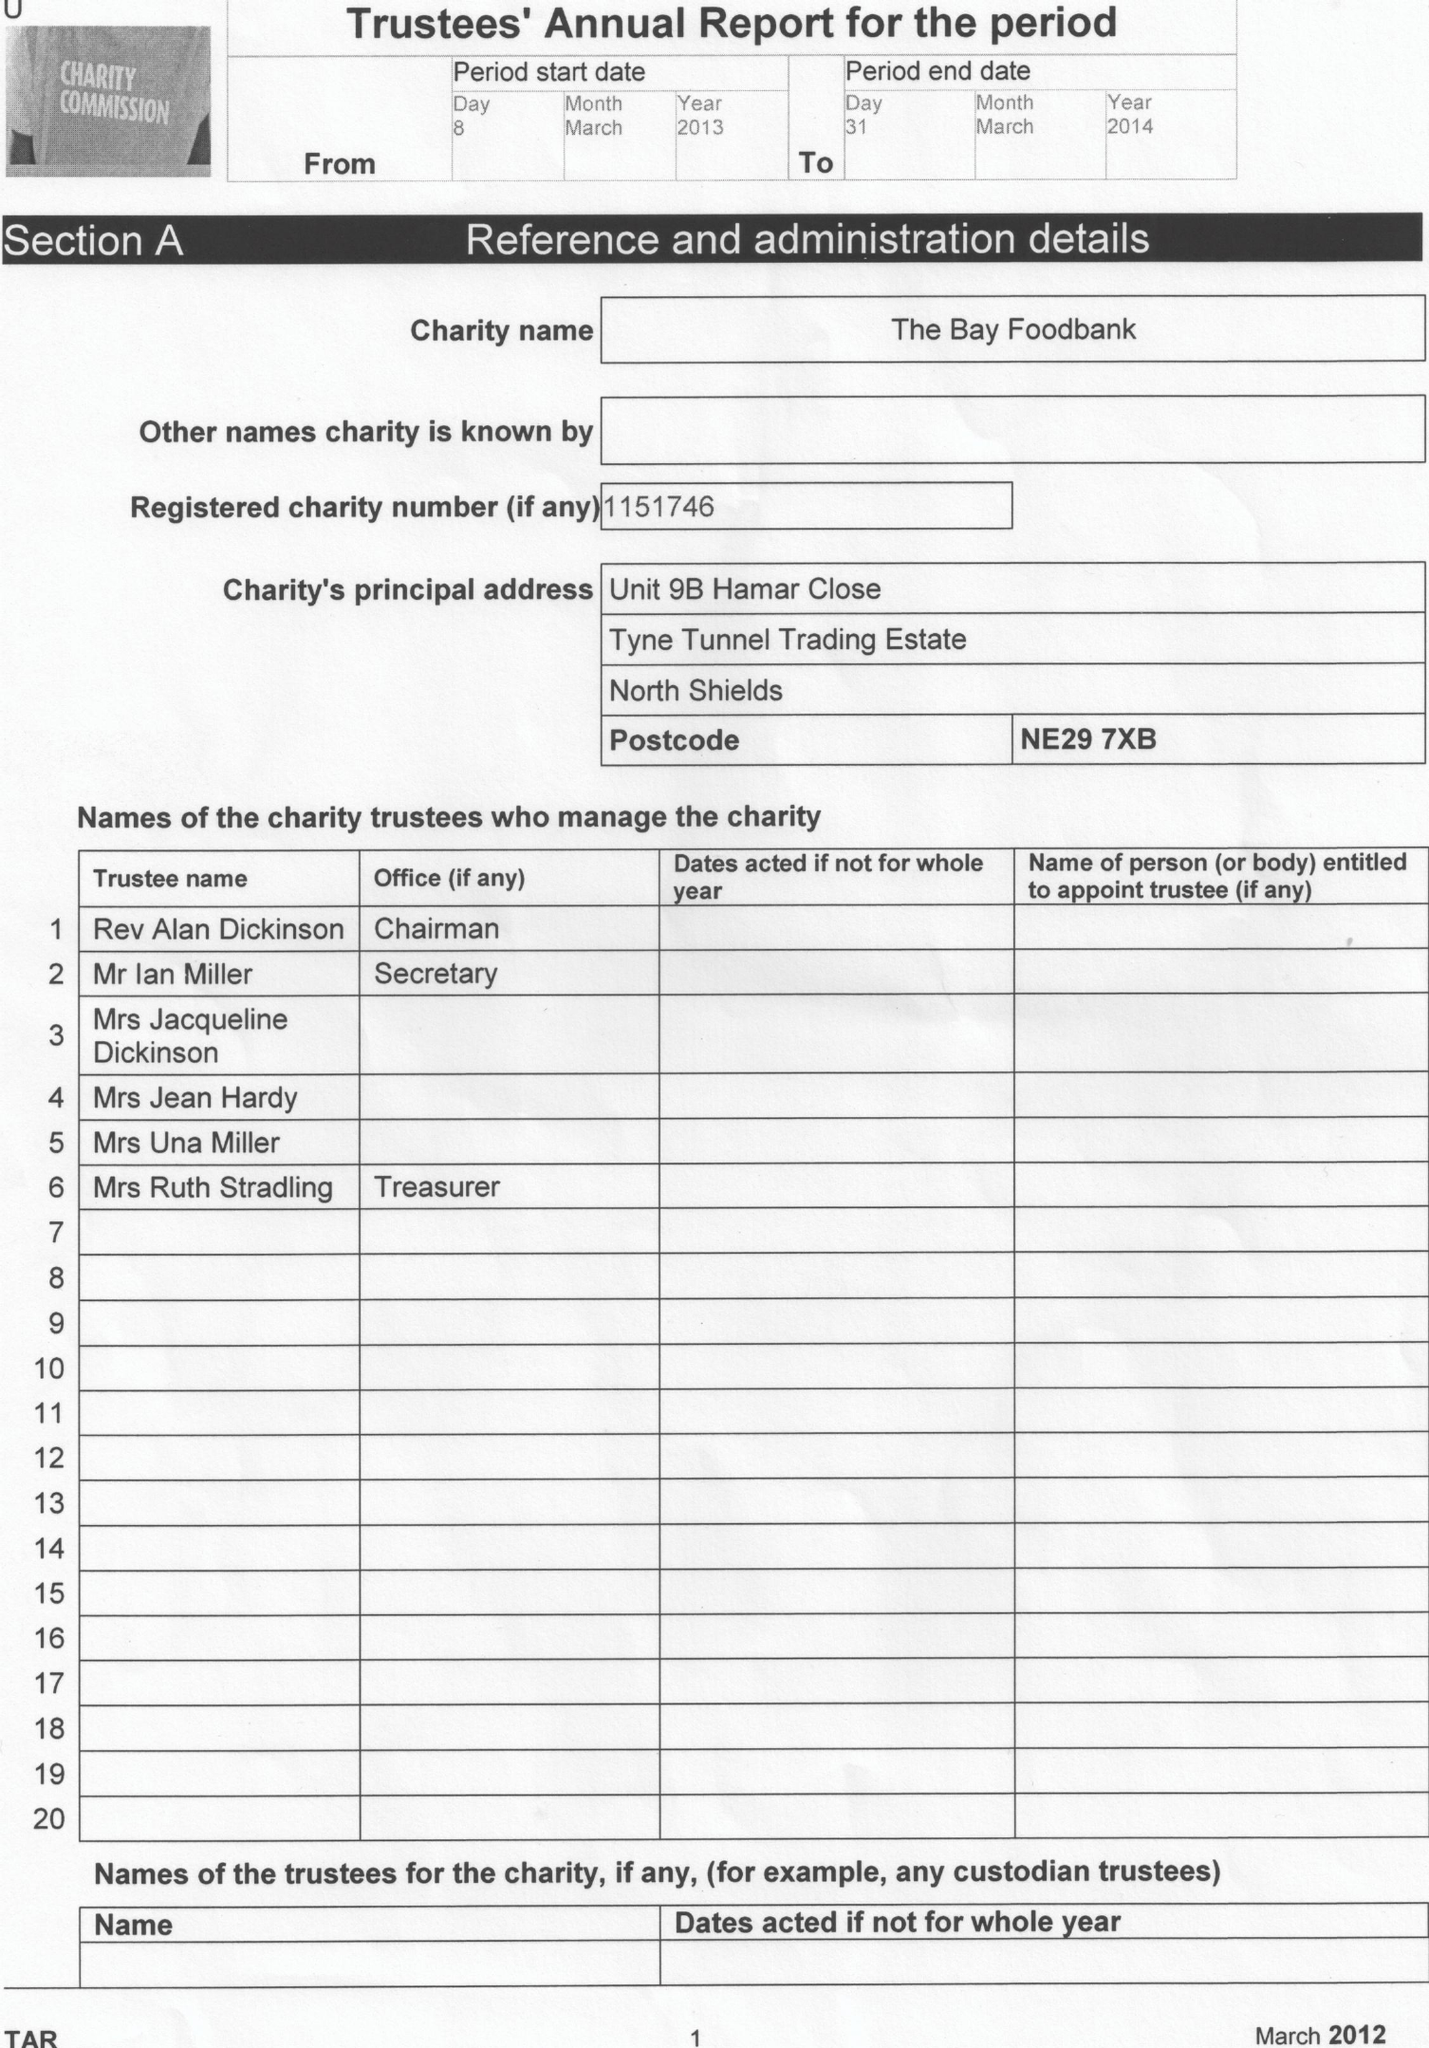What is the value for the address__post_town?
Answer the question using a single word or phrase. NORTH SHIELDS 